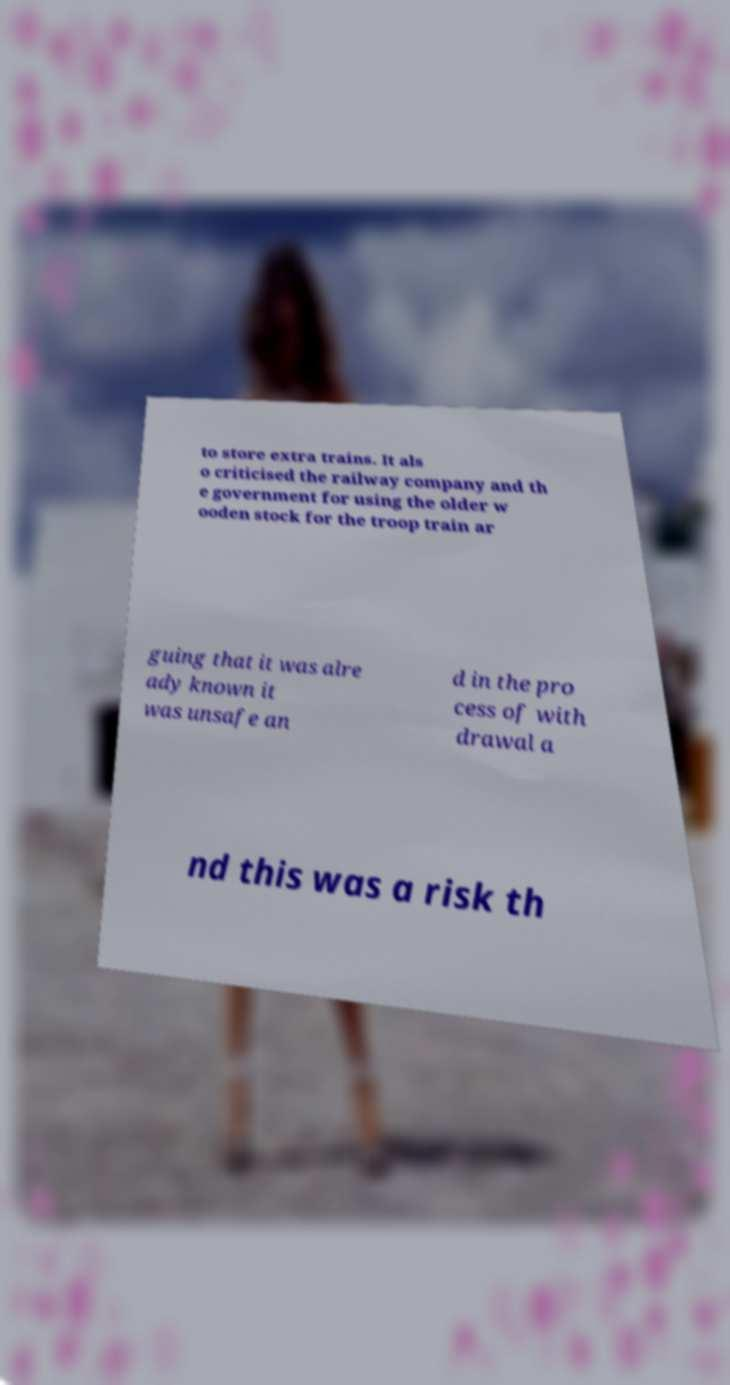I need the written content from this picture converted into text. Can you do that? to store extra trains. It als o criticised the railway company and th e government for using the older w ooden stock for the troop train ar guing that it was alre ady known it was unsafe an d in the pro cess of with drawal a nd this was a risk th 